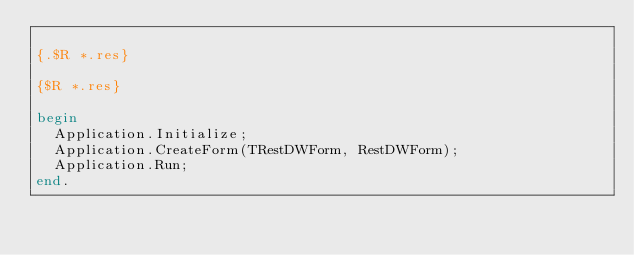<code> <loc_0><loc_0><loc_500><loc_500><_Pascal_>
{.$R *.res}

{$R *.res}

begin
  Application.Initialize;
  Application.CreateForm(TRestDWForm, RestDWForm);
  Application.Run;
end.
</code> 